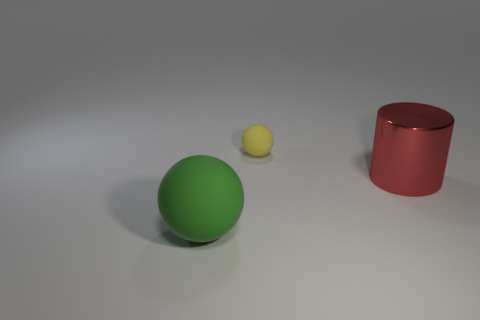Add 3 cylinders. How many objects exist? 6 Subtract all cylinders. How many objects are left? 2 Subtract 0 purple cubes. How many objects are left? 3 Subtract all large red shiny cylinders. Subtract all balls. How many objects are left? 0 Add 2 large rubber balls. How many large rubber balls are left? 3 Add 2 yellow matte objects. How many yellow matte objects exist? 3 